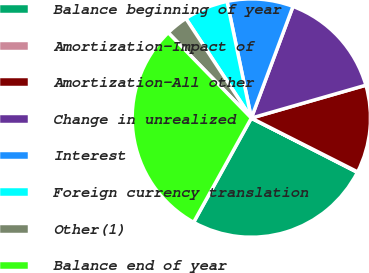Convert chart. <chart><loc_0><loc_0><loc_500><loc_500><pie_chart><fcel>Balance beginning of year<fcel>Amortization-Impact of<fcel>Amortization-All other<fcel>Change in unrealized<fcel>Interest<fcel>Foreign currency translation<fcel>Other(1)<fcel>Balance end of year<nl><fcel>25.52%<fcel>0.07%<fcel>11.91%<fcel>14.87%<fcel>8.95%<fcel>5.99%<fcel>3.03%<fcel>29.67%<nl></chart> 